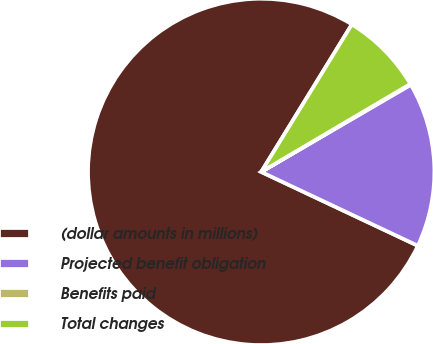Convert chart. <chart><loc_0><loc_0><loc_500><loc_500><pie_chart><fcel>(dollar amounts in millions)<fcel>Projected benefit obligation<fcel>Benefits paid<fcel>Total changes<nl><fcel>76.76%<fcel>15.41%<fcel>0.08%<fcel>7.75%<nl></chart> 